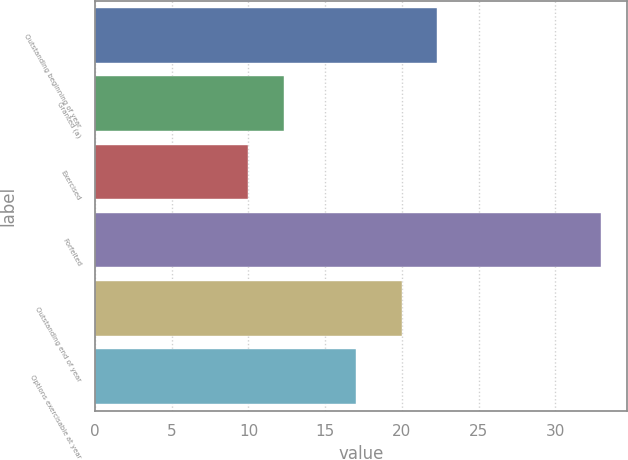<chart> <loc_0><loc_0><loc_500><loc_500><bar_chart><fcel>Outstanding beginning of year<fcel>Granted (a)<fcel>Exercised<fcel>Forfeited<fcel>Outstanding end of year<fcel>Options exercisable at year<nl><fcel>22.3<fcel>12.3<fcel>10<fcel>33<fcel>20<fcel>17<nl></chart> 